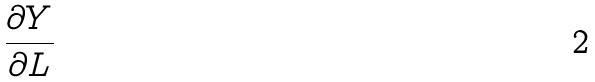<formula> <loc_0><loc_0><loc_500><loc_500>\frac { \partial Y } { \partial L }</formula> 